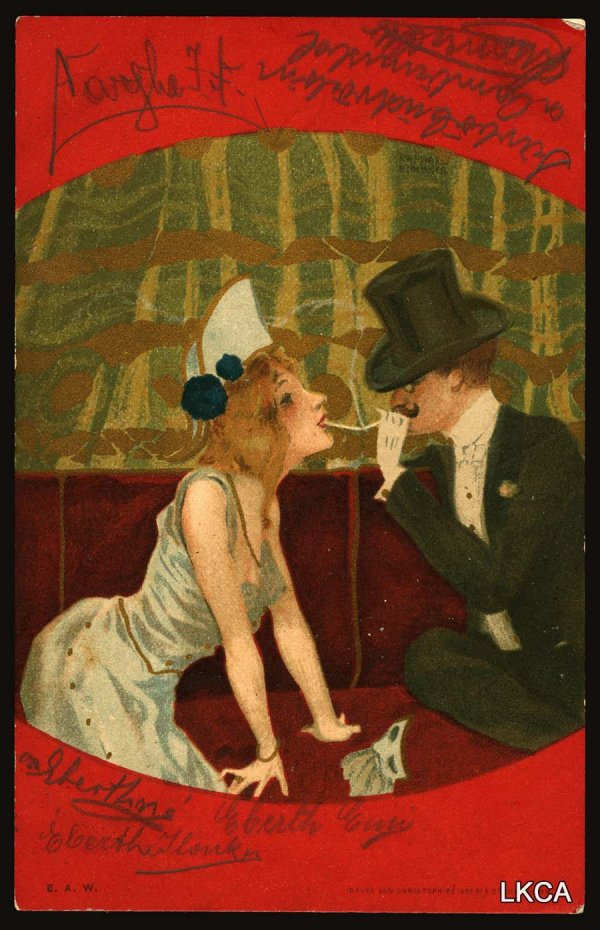Imagine this image is part of a series illustrating a fictional 20th-century love story. Create a detailed narration of this specific moment in the context of the larger story. In the heart of 1920s Vienna, an era brimming with artistic revolution and cultural vibrancy, lives Lucia, a free-spirited artist, and Emil, a reserved but talented writer. Their paths cross one fateful evening during an art exhibit, where an electric spark of familiarity and intrigue binds them instantly. Months pass, filled with clandestine meetings amidst the ornate cafes, moonlit strolls along the Danube, and long hours spent together in Lucia's art studio. This scene captures a pivotal moment in their love story: Emil, after much introspection, decides to profess the depths of his love. He invites Lucia to his favorite hidden café, where, amidst the richness of crimson velvet and lush green backdrops, he quietly unveils a secret. With a heartfelt whisper, Emil presents Lucia with a token of his affection, a delicate piece of poetry composed just for her. As they share a tender gaze, they both realize the profound truth—that their love has become an indelible part of their beings, to be cherished forever. 